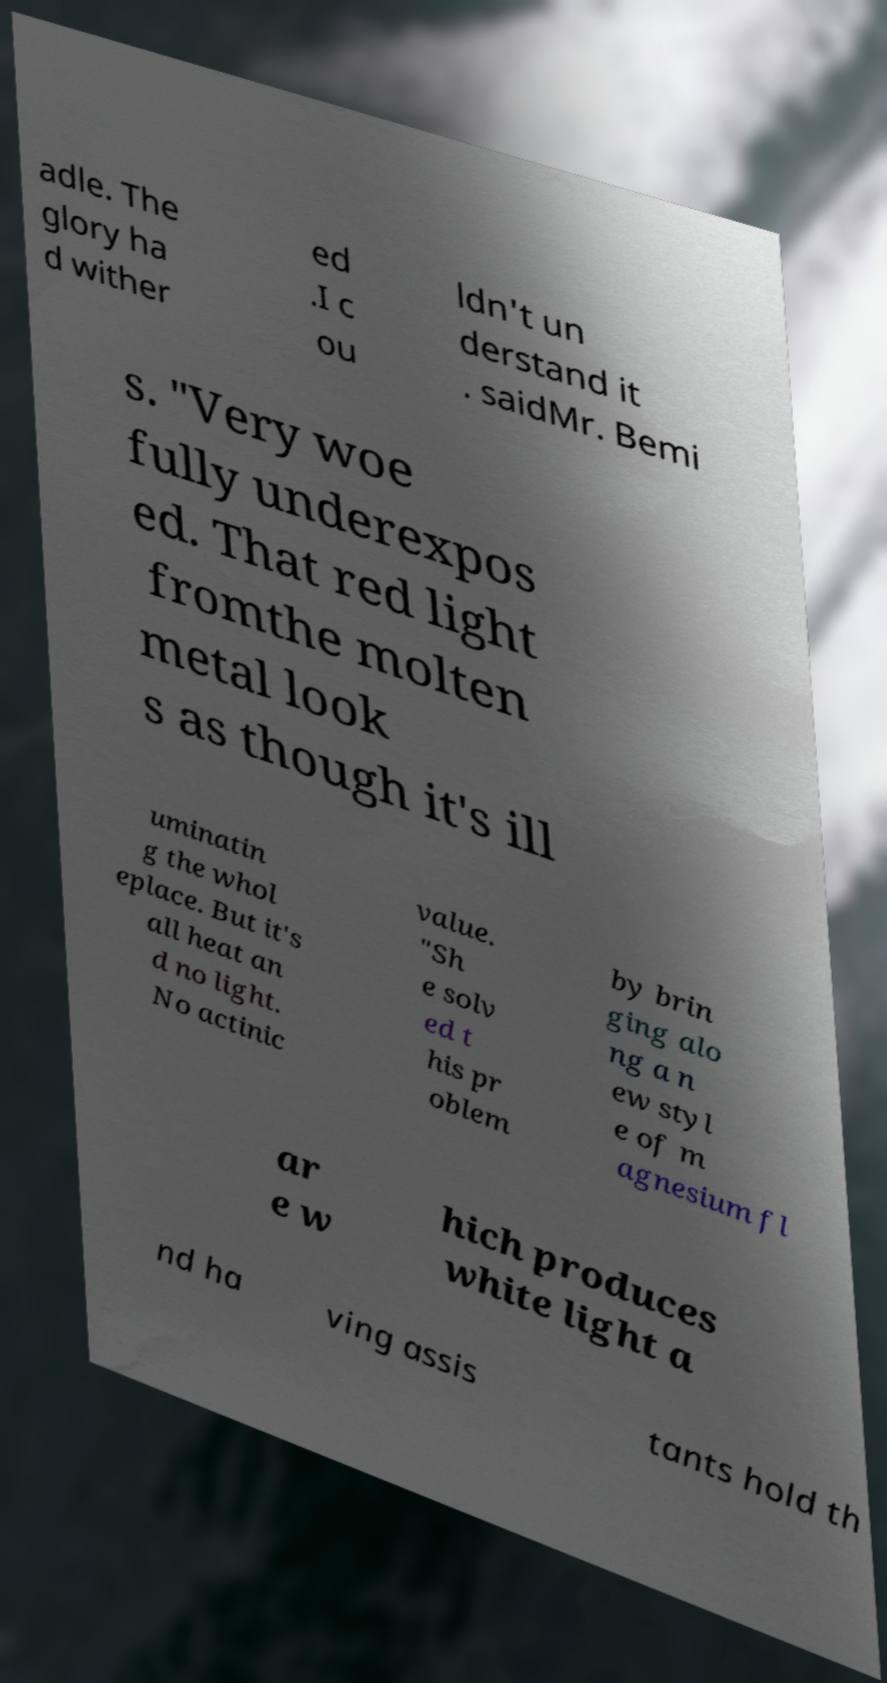Could you extract and type out the text from this image? adle. The glory ha d wither ed .I c ou ldn't un derstand it . saidMr. Bemi s. "Very woe fully underexpos ed. That red light fromthe molten metal look s as though it's ill uminatin g the whol eplace. But it's all heat an d no light. No actinic value. "Sh e solv ed t his pr oblem by brin ging alo ng a n ew styl e of m agnesium fl ar e w hich produces white light a nd ha ving assis tants hold th 